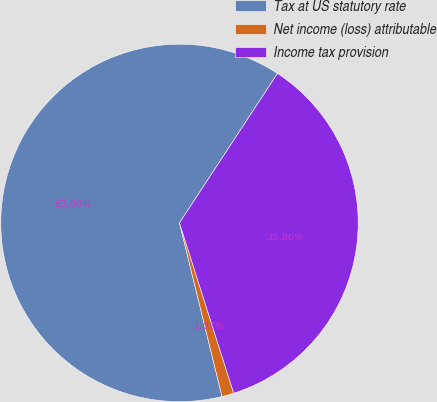<chart> <loc_0><loc_0><loc_500><loc_500><pie_chart><fcel>Tax at US statutory rate<fcel>Net income (loss) attributable<fcel>Income tax provision<nl><fcel>63.06%<fcel>1.08%<fcel>35.86%<nl></chart> 